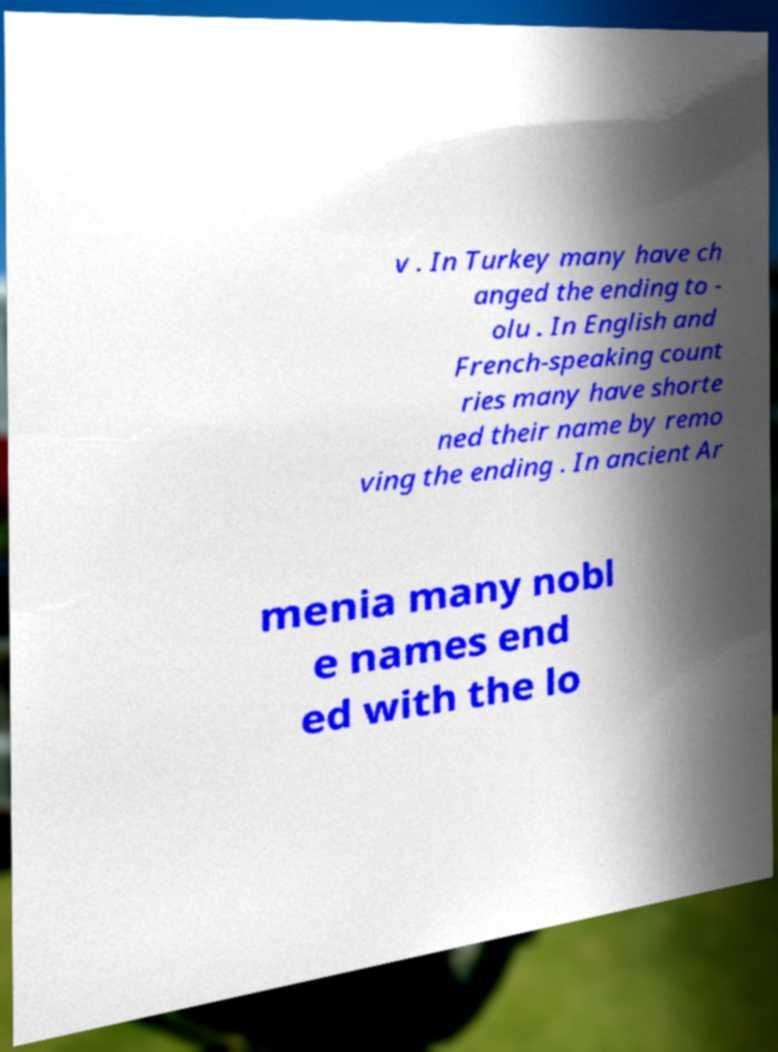Could you assist in decoding the text presented in this image and type it out clearly? v . In Turkey many have ch anged the ending to - olu . In English and French-speaking count ries many have shorte ned their name by remo ving the ending . In ancient Ar menia many nobl e names end ed with the lo 